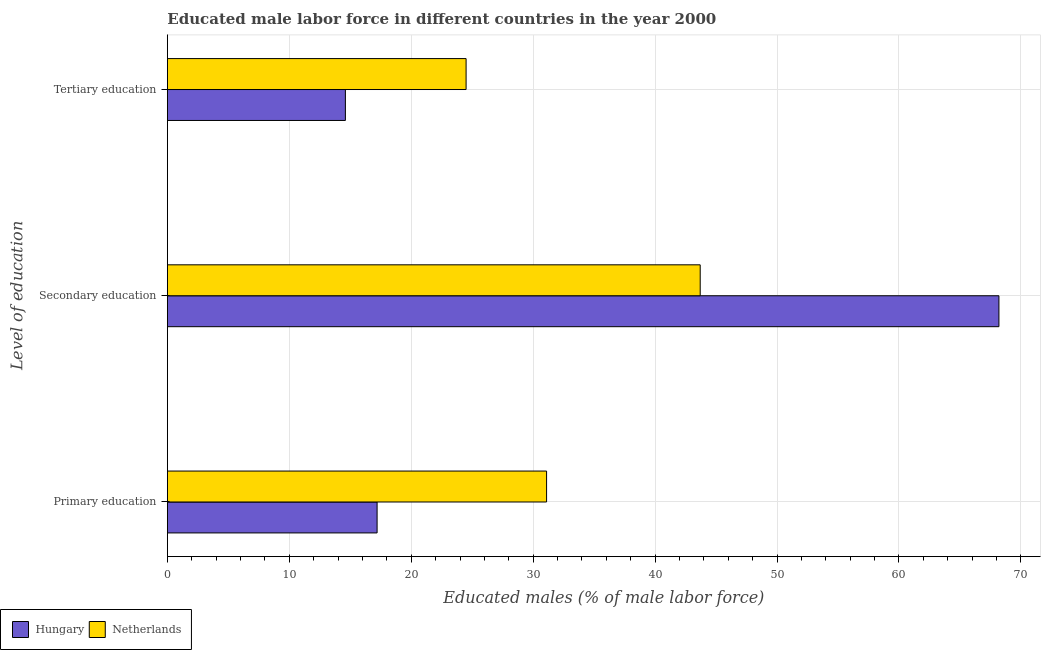How many different coloured bars are there?
Offer a very short reply. 2. How many groups of bars are there?
Make the answer very short. 3. How many bars are there on the 2nd tick from the top?
Offer a terse response. 2. How many bars are there on the 1st tick from the bottom?
Keep it short and to the point. 2. What is the label of the 3rd group of bars from the top?
Make the answer very short. Primary education. What is the percentage of male labor force who received secondary education in Netherlands?
Provide a succinct answer. 43.7. Across all countries, what is the maximum percentage of male labor force who received secondary education?
Offer a terse response. 68.2. Across all countries, what is the minimum percentage of male labor force who received primary education?
Provide a short and direct response. 17.2. In which country was the percentage of male labor force who received tertiary education maximum?
Your answer should be very brief. Netherlands. In which country was the percentage of male labor force who received secondary education minimum?
Provide a short and direct response. Netherlands. What is the total percentage of male labor force who received tertiary education in the graph?
Ensure brevity in your answer.  39.1. What is the difference between the percentage of male labor force who received secondary education in Hungary and that in Netherlands?
Give a very brief answer. 24.5. What is the difference between the percentage of male labor force who received secondary education in Netherlands and the percentage of male labor force who received tertiary education in Hungary?
Provide a succinct answer. 29.1. What is the average percentage of male labor force who received tertiary education per country?
Offer a terse response. 19.55. What is the difference between the percentage of male labor force who received primary education and percentage of male labor force who received tertiary education in Netherlands?
Provide a short and direct response. 6.6. What is the ratio of the percentage of male labor force who received tertiary education in Netherlands to that in Hungary?
Offer a very short reply. 1.68. Is the percentage of male labor force who received tertiary education in Hungary less than that in Netherlands?
Your answer should be very brief. Yes. Is the difference between the percentage of male labor force who received secondary education in Netherlands and Hungary greater than the difference between the percentage of male labor force who received primary education in Netherlands and Hungary?
Provide a succinct answer. No. What is the difference between the highest and the second highest percentage of male labor force who received secondary education?
Make the answer very short. 24.5. What is the difference between the highest and the lowest percentage of male labor force who received tertiary education?
Your answer should be very brief. 9.9. In how many countries, is the percentage of male labor force who received primary education greater than the average percentage of male labor force who received primary education taken over all countries?
Provide a short and direct response. 1. What does the 2nd bar from the bottom in Primary education represents?
Offer a very short reply. Netherlands. What is the difference between two consecutive major ticks on the X-axis?
Your answer should be compact. 10. Does the graph contain grids?
Your answer should be very brief. Yes. How many legend labels are there?
Your answer should be compact. 2. How are the legend labels stacked?
Your answer should be compact. Horizontal. What is the title of the graph?
Offer a terse response. Educated male labor force in different countries in the year 2000. Does "Lao PDR" appear as one of the legend labels in the graph?
Offer a very short reply. No. What is the label or title of the X-axis?
Make the answer very short. Educated males (% of male labor force). What is the label or title of the Y-axis?
Your answer should be very brief. Level of education. What is the Educated males (% of male labor force) in Hungary in Primary education?
Provide a short and direct response. 17.2. What is the Educated males (% of male labor force) in Netherlands in Primary education?
Give a very brief answer. 31.1. What is the Educated males (% of male labor force) in Hungary in Secondary education?
Give a very brief answer. 68.2. What is the Educated males (% of male labor force) of Netherlands in Secondary education?
Make the answer very short. 43.7. What is the Educated males (% of male labor force) in Hungary in Tertiary education?
Your response must be concise. 14.6. What is the Educated males (% of male labor force) in Netherlands in Tertiary education?
Provide a short and direct response. 24.5. Across all Level of education, what is the maximum Educated males (% of male labor force) of Hungary?
Provide a short and direct response. 68.2. Across all Level of education, what is the maximum Educated males (% of male labor force) of Netherlands?
Your answer should be compact. 43.7. Across all Level of education, what is the minimum Educated males (% of male labor force) in Hungary?
Keep it short and to the point. 14.6. Across all Level of education, what is the minimum Educated males (% of male labor force) in Netherlands?
Offer a very short reply. 24.5. What is the total Educated males (% of male labor force) of Netherlands in the graph?
Ensure brevity in your answer.  99.3. What is the difference between the Educated males (% of male labor force) in Hungary in Primary education and that in Secondary education?
Give a very brief answer. -51. What is the difference between the Educated males (% of male labor force) of Hungary in Primary education and that in Tertiary education?
Offer a very short reply. 2.6. What is the difference between the Educated males (% of male labor force) of Netherlands in Primary education and that in Tertiary education?
Offer a terse response. 6.6. What is the difference between the Educated males (% of male labor force) in Hungary in Secondary education and that in Tertiary education?
Ensure brevity in your answer.  53.6. What is the difference between the Educated males (% of male labor force) in Netherlands in Secondary education and that in Tertiary education?
Your answer should be very brief. 19.2. What is the difference between the Educated males (% of male labor force) in Hungary in Primary education and the Educated males (% of male labor force) in Netherlands in Secondary education?
Make the answer very short. -26.5. What is the difference between the Educated males (% of male labor force) in Hungary in Primary education and the Educated males (% of male labor force) in Netherlands in Tertiary education?
Ensure brevity in your answer.  -7.3. What is the difference between the Educated males (% of male labor force) in Hungary in Secondary education and the Educated males (% of male labor force) in Netherlands in Tertiary education?
Offer a very short reply. 43.7. What is the average Educated males (% of male labor force) of Hungary per Level of education?
Provide a short and direct response. 33.33. What is the average Educated males (% of male labor force) of Netherlands per Level of education?
Ensure brevity in your answer.  33.1. What is the difference between the Educated males (% of male labor force) in Hungary and Educated males (% of male labor force) in Netherlands in Primary education?
Offer a terse response. -13.9. What is the difference between the Educated males (% of male labor force) in Hungary and Educated males (% of male labor force) in Netherlands in Secondary education?
Ensure brevity in your answer.  24.5. What is the difference between the Educated males (% of male labor force) in Hungary and Educated males (% of male labor force) in Netherlands in Tertiary education?
Make the answer very short. -9.9. What is the ratio of the Educated males (% of male labor force) in Hungary in Primary education to that in Secondary education?
Offer a terse response. 0.25. What is the ratio of the Educated males (% of male labor force) of Netherlands in Primary education to that in Secondary education?
Provide a succinct answer. 0.71. What is the ratio of the Educated males (% of male labor force) in Hungary in Primary education to that in Tertiary education?
Offer a very short reply. 1.18. What is the ratio of the Educated males (% of male labor force) in Netherlands in Primary education to that in Tertiary education?
Provide a short and direct response. 1.27. What is the ratio of the Educated males (% of male labor force) in Hungary in Secondary education to that in Tertiary education?
Offer a very short reply. 4.67. What is the ratio of the Educated males (% of male labor force) of Netherlands in Secondary education to that in Tertiary education?
Ensure brevity in your answer.  1.78. What is the difference between the highest and the second highest Educated males (% of male labor force) of Hungary?
Your response must be concise. 51. What is the difference between the highest and the second highest Educated males (% of male labor force) of Netherlands?
Ensure brevity in your answer.  12.6. What is the difference between the highest and the lowest Educated males (% of male labor force) in Hungary?
Your answer should be very brief. 53.6. What is the difference between the highest and the lowest Educated males (% of male labor force) in Netherlands?
Provide a succinct answer. 19.2. 